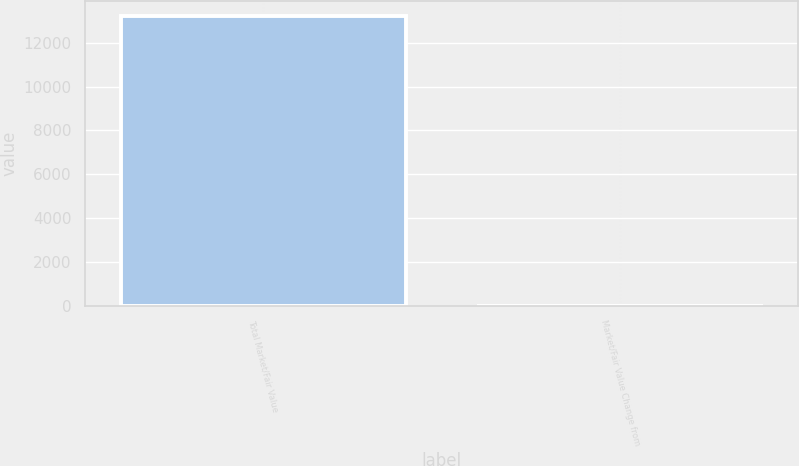Convert chart to OTSL. <chart><loc_0><loc_0><loc_500><loc_500><bar_chart><fcel>Total Market/Fair Value<fcel>Market/Fair Value Change from<nl><fcel>13228.2<fcel>5.8<nl></chart> 